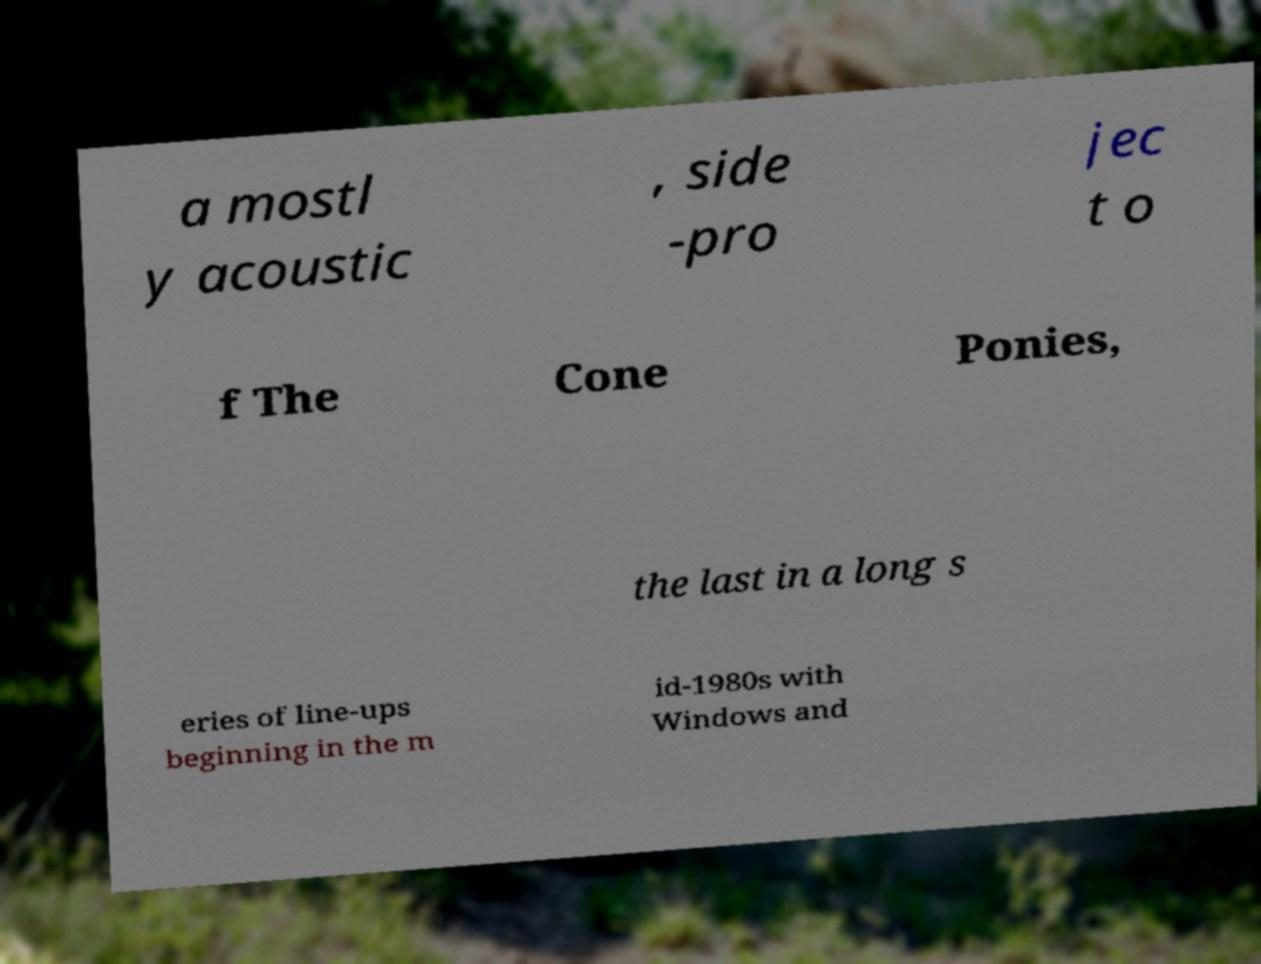Can you accurately transcribe the text from the provided image for me? a mostl y acoustic , side -pro jec t o f The Cone Ponies, the last in a long s eries of line-ups beginning in the m id-1980s with Windows and 